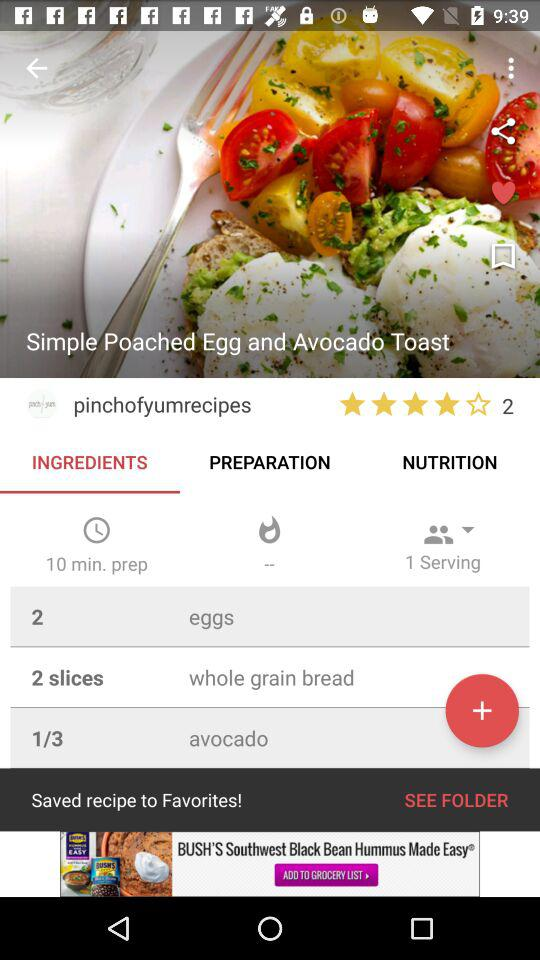How many people can the dish be served to? The dish can be served to one person. 